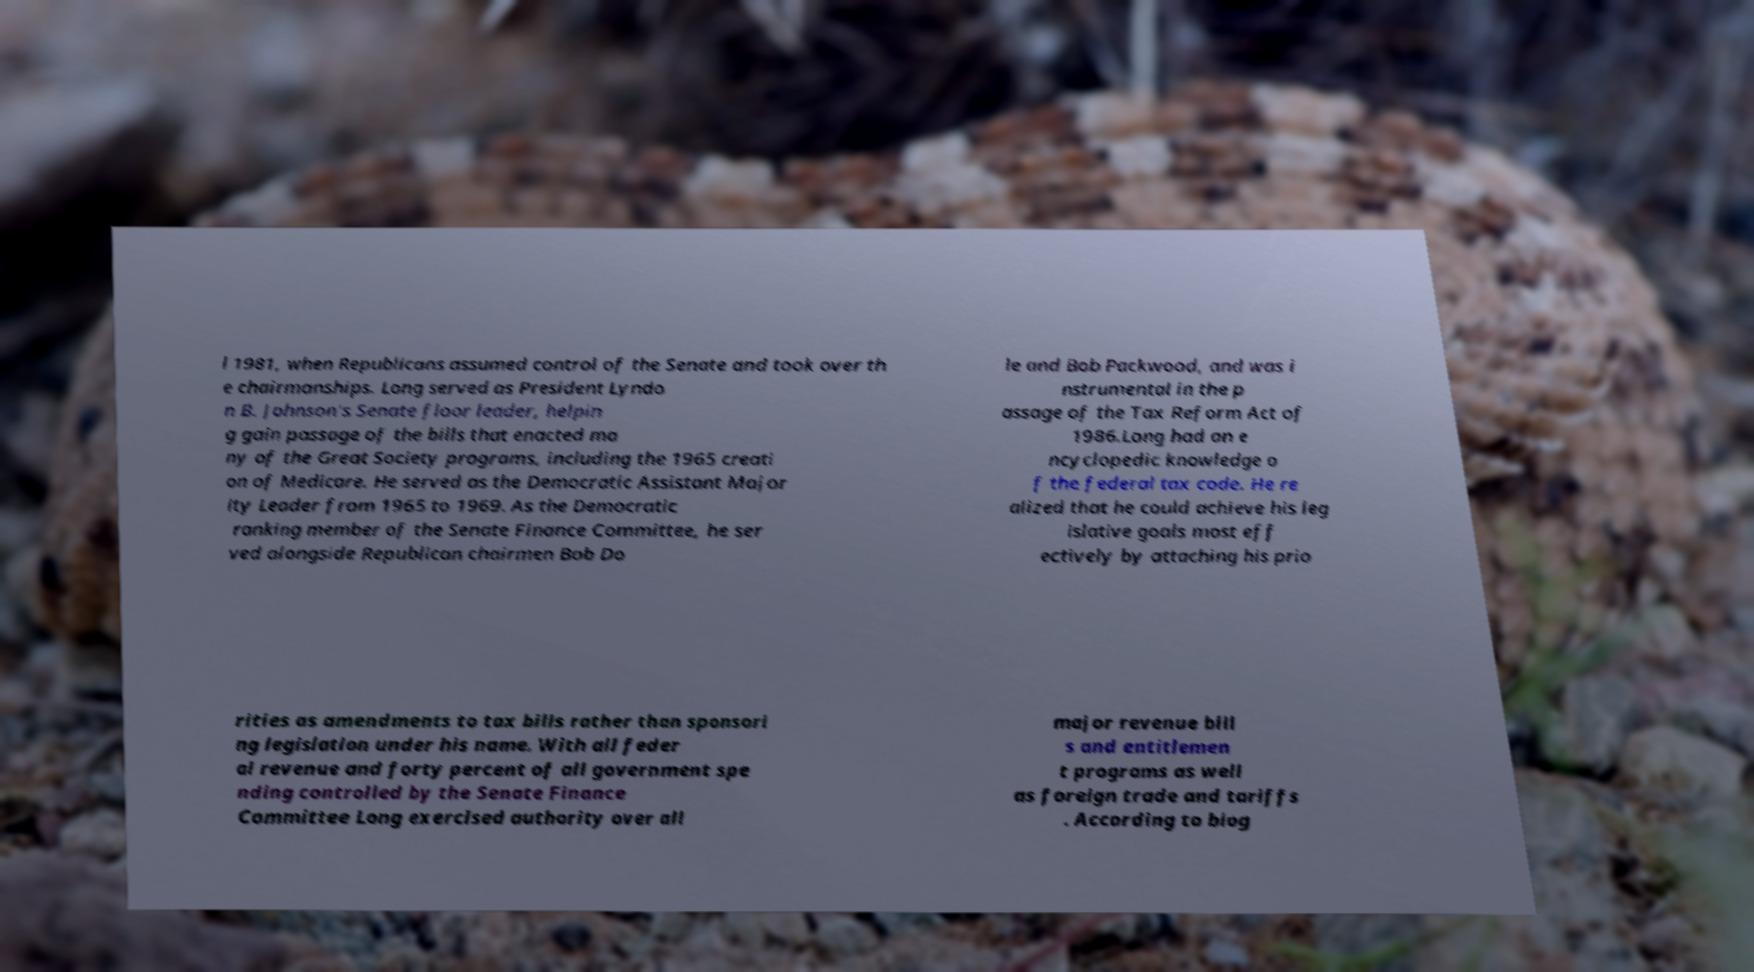Please identify and transcribe the text found in this image. l 1981, when Republicans assumed control of the Senate and took over th e chairmanships. Long served as President Lyndo n B. Johnson's Senate floor leader, helpin g gain passage of the bills that enacted ma ny of the Great Society programs, including the 1965 creati on of Medicare. He served as the Democratic Assistant Major ity Leader from 1965 to 1969. As the Democratic ranking member of the Senate Finance Committee, he ser ved alongside Republican chairmen Bob Do le and Bob Packwood, and was i nstrumental in the p assage of the Tax Reform Act of 1986.Long had an e ncyclopedic knowledge o f the federal tax code. He re alized that he could achieve his leg islative goals most eff ectively by attaching his prio rities as amendments to tax bills rather than sponsori ng legislation under his name. With all feder al revenue and forty percent of all government spe nding controlled by the Senate Finance Committee Long exercised authority over all major revenue bill s and entitlemen t programs as well as foreign trade and tariffs . According to biog 